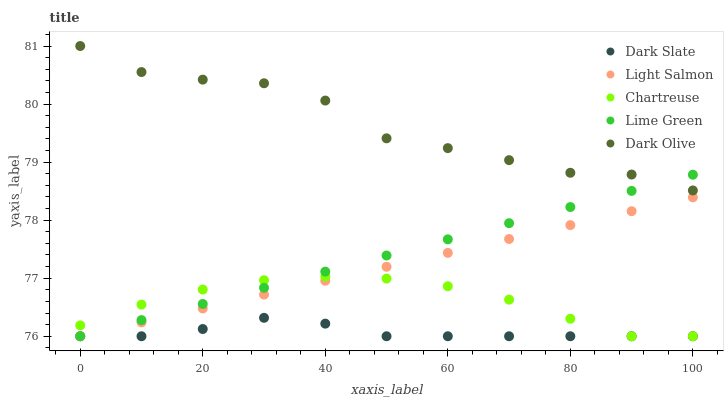Does Dark Slate have the minimum area under the curve?
Answer yes or no. Yes. Does Dark Olive have the maximum area under the curve?
Answer yes or no. Yes. Does Light Salmon have the minimum area under the curve?
Answer yes or no. No. Does Light Salmon have the maximum area under the curve?
Answer yes or no. No. Is Lime Green the smoothest?
Answer yes or no. Yes. Is Dark Olive the roughest?
Answer yes or no. Yes. Is Light Salmon the smoothest?
Answer yes or no. No. Is Light Salmon the roughest?
Answer yes or no. No. Does Dark Slate have the lowest value?
Answer yes or no. Yes. Does Dark Olive have the lowest value?
Answer yes or no. No. Does Dark Olive have the highest value?
Answer yes or no. Yes. Does Light Salmon have the highest value?
Answer yes or no. No. Is Dark Slate less than Dark Olive?
Answer yes or no. Yes. Is Dark Olive greater than Dark Slate?
Answer yes or no. Yes. Does Light Salmon intersect Chartreuse?
Answer yes or no. Yes. Is Light Salmon less than Chartreuse?
Answer yes or no. No. Is Light Salmon greater than Chartreuse?
Answer yes or no. No. Does Dark Slate intersect Dark Olive?
Answer yes or no. No. 